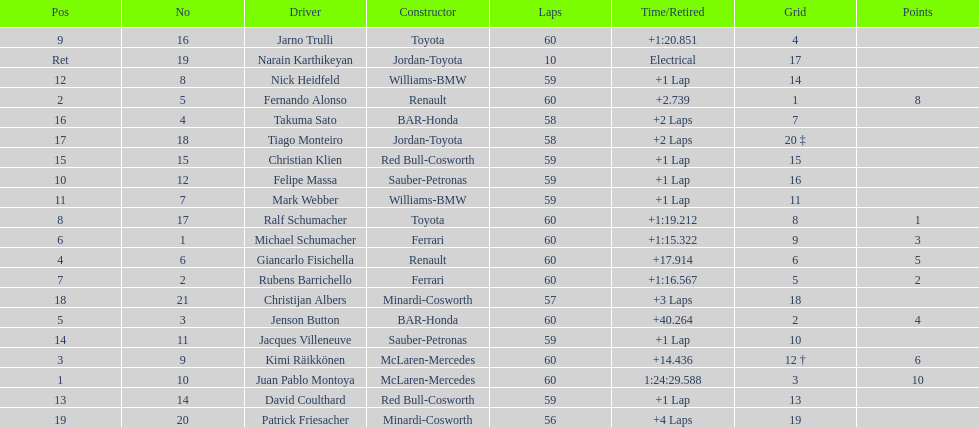Which driver came after giancarlo fisichella? Jenson Button. 